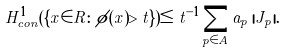<formula> <loc_0><loc_0><loc_500><loc_500>H ^ { 1 } _ { c o n } ( \{ x \in { R } \colon \phi ( x ) > t \} ) \leq t ^ { - 1 } \sum _ { p \in A } a _ { p } \, | J _ { p } | .</formula> 